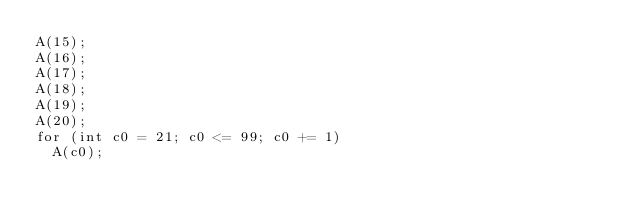Convert code to text. <code><loc_0><loc_0><loc_500><loc_500><_C_>A(15);
A(16);
A(17);
A(18);
A(19);
A(20);
for (int c0 = 21; c0 <= 99; c0 += 1)
  A(c0);
</code> 